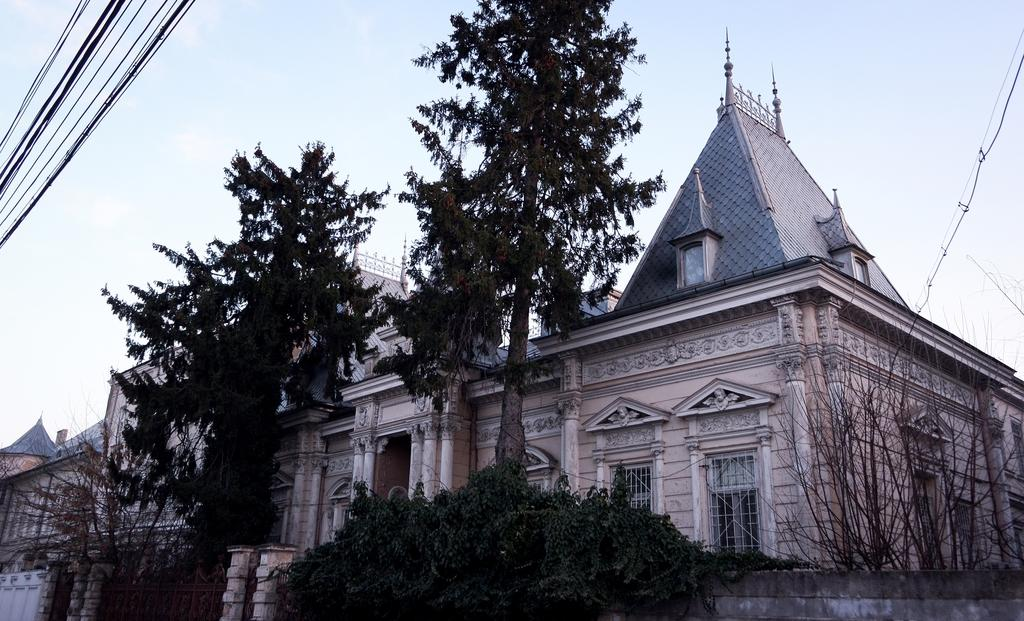What type of structures can be seen in the image? There are many houses in the image. What is the natural environment surrounding the houses? The houses are surrounded by trees and bushes. What else can be seen in the image besides the houses and vegetation? There are wires visible in the image. What is the color of the sky in the image? The sky is blue in the image. Where can the coal be found in the image? There is no coal present in the image. What is the afterthought of the person who took the picture? We cannot determine the afterthought of the person who took the picture from the image itself. 